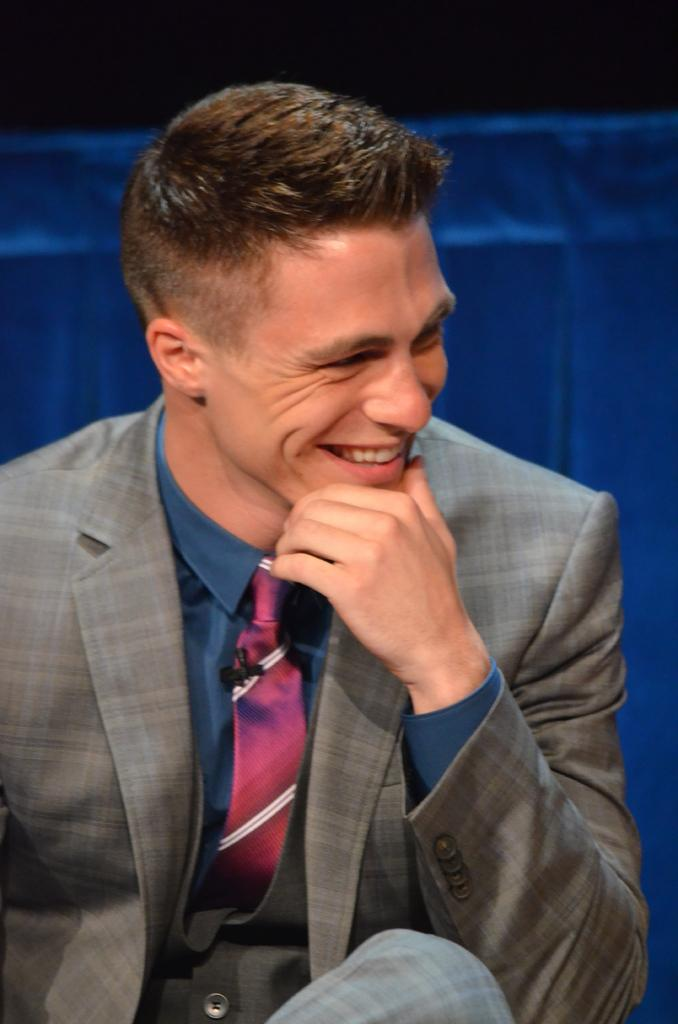Who or what is the main subject in the image? There is a person in the image. What is the person wearing? The person is wearing a suit. What can be seen in the background of the image? There is a blue colored cloth in the background of the image. What type of attraction can be seen in the background of the image? There is no attraction visible in the image; only a blue colored cloth is present in the background. What kind of structure is the person standing next to in the image? There is no structure visible in the image; only the person and the blue colored cloth are present. 